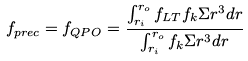<formula> <loc_0><loc_0><loc_500><loc_500>f _ { p r e c } = f _ { Q P O } = \frac { \int _ { r _ { i } } ^ { r _ { o } } f _ { L T } f _ { k } \Sigma r ^ { 3 } d r } { \int _ { r _ { i } } ^ { r _ { o } } f _ { k } \Sigma r ^ { 3 } d r }</formula> 